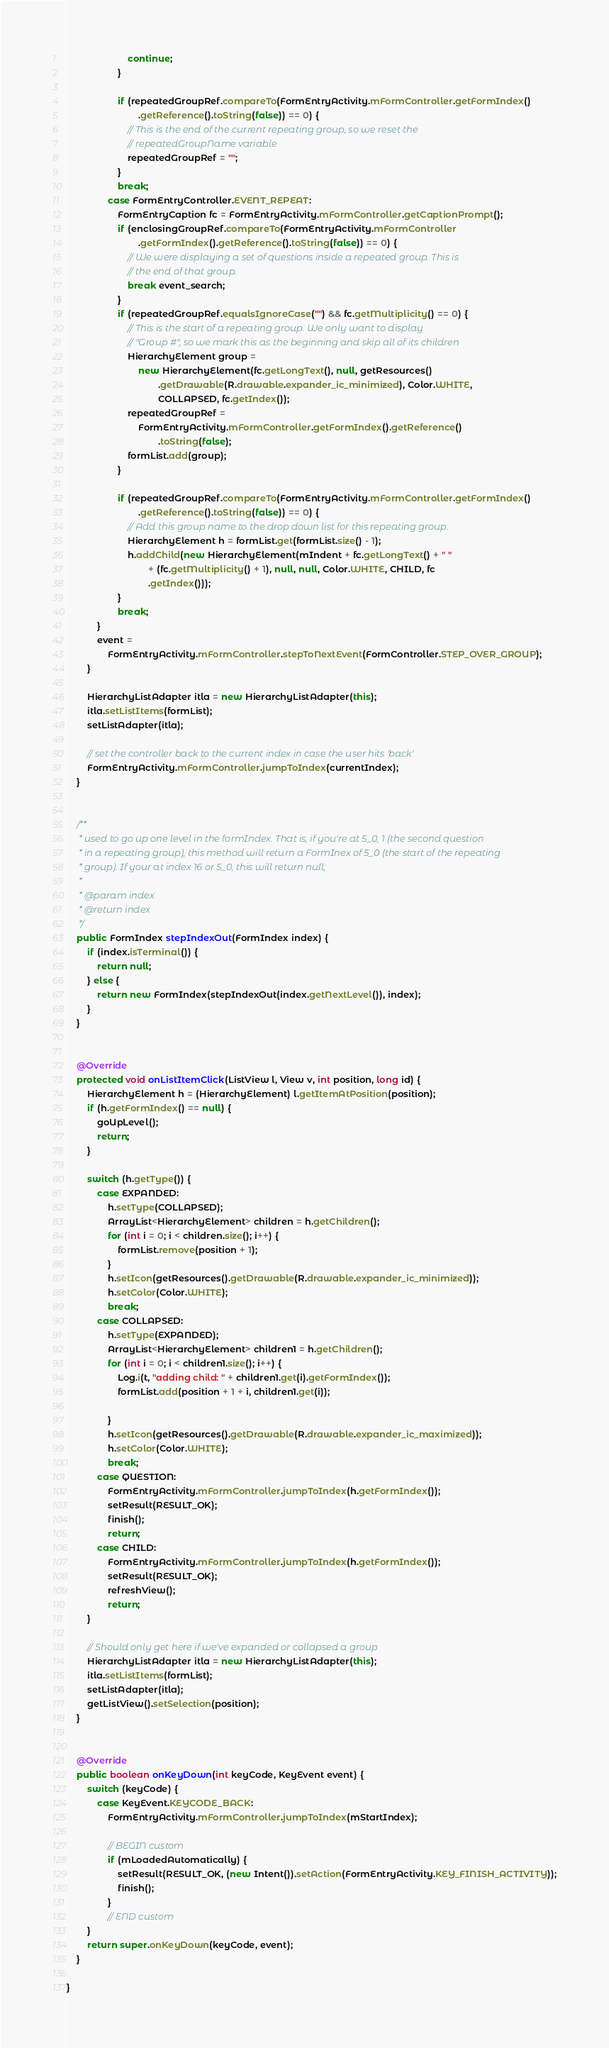<code> <loc_0><loc_0><loc_500><loc_500><_Java_>                        continue;
                    }

                    if (repeatedGroupRef.compareTo(FormEntryActivity.mFormController.getFormIndex()
                            .getReference().toString(false)) == 0) {
                        // This is the end of the current repeating group, so we reset the
                        // repeatedGroupName variable
                        repeatedGroupRef = "";
                    }
                    break;
                case FormEntryController.EVENT_REPEAT:
                    FormEntryCaption fc = FormEntryActivity.mFormController.getCaptionPrompt();
                    if (enclosingGroupRef.compareTo(FormEntryActivity.mFormController
                            .getFormIndex().getReference().toString(false)) == 0) {
                        // We were displaying a set of questions inside a repeated group. This is
                        // the end of that group.
                        break event_search;
                    }
                    if (repeatedGroupRef.equalsIgnoreCase("") && fc.getMultiplicity() == 0) {
                        // This is the start of a repeating group. We only want to display
                        // "Group #", so we mark this as the beginning and skip all of its children
                        HierarchyElement group =
                            new HierarchyElement(fc.getLongText(), null, getResources()
                                    .getDrawable(R.drawable.expander_ic_minimized), Color.WHITE,
                                    COLLAPSED, fc.getIndex());
                        repeatedGroupRef =
                            FormEntryActivity.mFormController.getFormIndex().getReference()
                                    .toString(false);
                        formList.add(group);
                    }

                    if (repeatedGroupRef.compareTo(FormEntryActivity.mFormController.getFormIndex()
                            .getReference().toString(false)) == 0) {
                        // Add this group name to the drop down list for this repeating group.
                        HierarchyElement h = formList.get(formList.size() - 1);
                        h.addChild(new HierarchyElement(mIndent + fc.getLongText() + " "
                                + (fc.getMultiplicity() + 1), null, null, Color.WHITE, CHILD, fc
                                .getIndex()));
                    }
                    break;
            }
            event =
                FormEntryActivity.mFormController.stepToNextEvent(FormController.STEP_OVER_GROUP);
        }

        HierarchyListAdapter itla = new HierarchyListAdapter(this);
        itla.setListItems(formList);
        setListAdapter(itla);

        // set the controller back to the current index in case the user hits 'back'
        FormEntryActivity.mFormController.jumpToIndex(currentIndex);
    }


    /**
     * used to go up one level in the formIndex. That is, if you're at 5_0, 1 (the second question
     * in a repeating group), this method will return a FormInex of 5_0 (the start of the repeating
     * group). If your at index 16 or 5_0, this will return null;
     * 
     * @param index
     * @return index
     */
    public FormIndex stepIndexOut(FormIndex index) {
        if (index.isTerminal()) {
            return null;
        } else {
            return new FormIndex(stepIndexOut(index.getNextLevel()), index);
        }
    }


    @Override
    protected void onListItemClick(ListView l, View v, int position, long id) {
        HierarchyElement h = (HierarchyElement) l.getItemAtPosition(position);
        if (h.getFormIndex() == null) {
            goUpLevel();
            return;
        }

        switch (h.getType()) {
            case EXPANDED:
                h.setType(COLLAPSED);
                ArrayList<HierarchyElement> children = h.getChildren();
                for (int i = 0; i < children.size(); i++) {
                    formList.remove(position + 1);
                }
                h.setIcon(getResources().getDrawable(R.drawable.expander_ic_minimized));
                h.setColor(Color.WHITE);
                break;
            case COLLAPSED:
                h.setType(EXPANDED);
                ArrayList<HierarchyElement> children1 = h.getChildren();
                for (int i = 0; i < children1.size(); i++) {
                    Log.i(t, "adding child: " + children1.get(i).getFormIndex());
                    formList.add(position + 1 + i, children1.get(i));

                }
                h.setIcon(getResources().getDrawable(R.drawable.expander_ic_maximized));
                h.setColor(Color.WHITE);
                break;
            case QUESTION:
                FormEntryActivity.mFormController.jumpToIndex(h.getFormIndex());
                setResult(RESULT_OK);
                finish();
                return;
            case CHILD:
                FormEntryActivity.mFormController.jumpToIndex(h.getFormIndex());
                setResult(RESULT_OK);
                refreshView();
                return;
        }

        // Should only get here if we've expanded or collapsed a group
        HierarchyListAdapter itla = new HierarchyListAdapter(this);
        itla.setListItems(formList);
        setListAdapter(itla);
        getListView().setSelection(position);
    }


    @Override
    public boolean onKeyDown(int keyCode, KeyEvent event) {
        switch (keyCode) {
            case KeyEvent.KEYCODE_BACK:
                FormEntryActivity.mFormController.jumpToIndex(mStartIndex);
                
                // BEGIN custom
                if (mLoadedAutomatically) {
                    setResult(RESULT_OK, (new Intent()).setAction(FormEntryActivity.KEY_FINISH_ACTIVITY));
                    finish();
                }
                // END custom
        }
        return super.onKeyDown(keyCode, event);
    }

}
</code> 